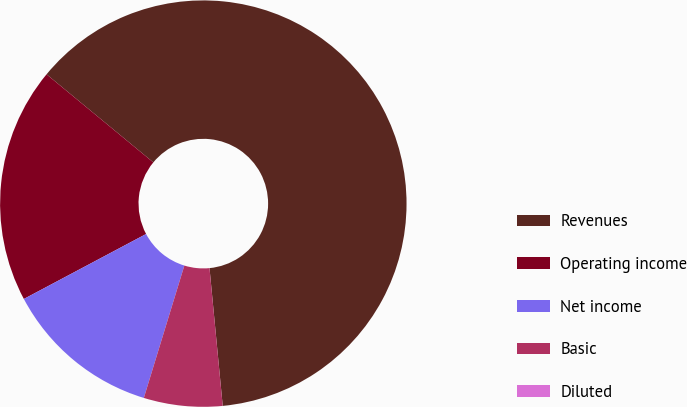Convert chart. <chart><loc_0><loc_0><loc_500><loc_500><pie_chart><fcel>Revenues<fcel>Operating income<fcel>Net income<fcel>Basic<fcel>Diluted<nl><fcel>62.5%<fcel>18.75%<fcel>12.5%<fcel>6.25%<fcel>0.0%<nl></chart> 